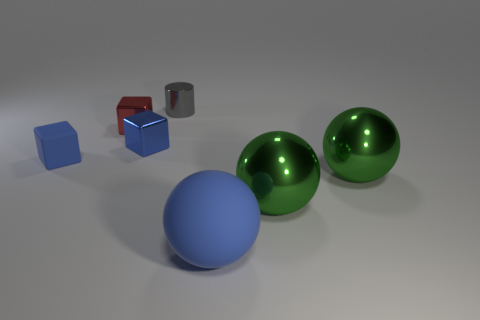Subtract all shiny balls. How many balls are left? 1 Subtract all blue cubes. How many cubes are left? 1 Add 2 small blue matte cubes. How many objects exist? 9 Subtract 1 blue balls. How many objects are left? 6 Subtract all cubes. How many objects are left? 4 Subtract 2 cubes. How many cubes are left? 1 Subtract all purple cylinders. Subtract all blue cubes. How many cylinders are left? 1 Subtract all cyan cylinders. How many blue cubes are left? 2 Subtract all blue rubber balls. Subtract all tiny gray things. How many objects are left? 5 Add 2 big metal things. How many big metal things are left? 4 